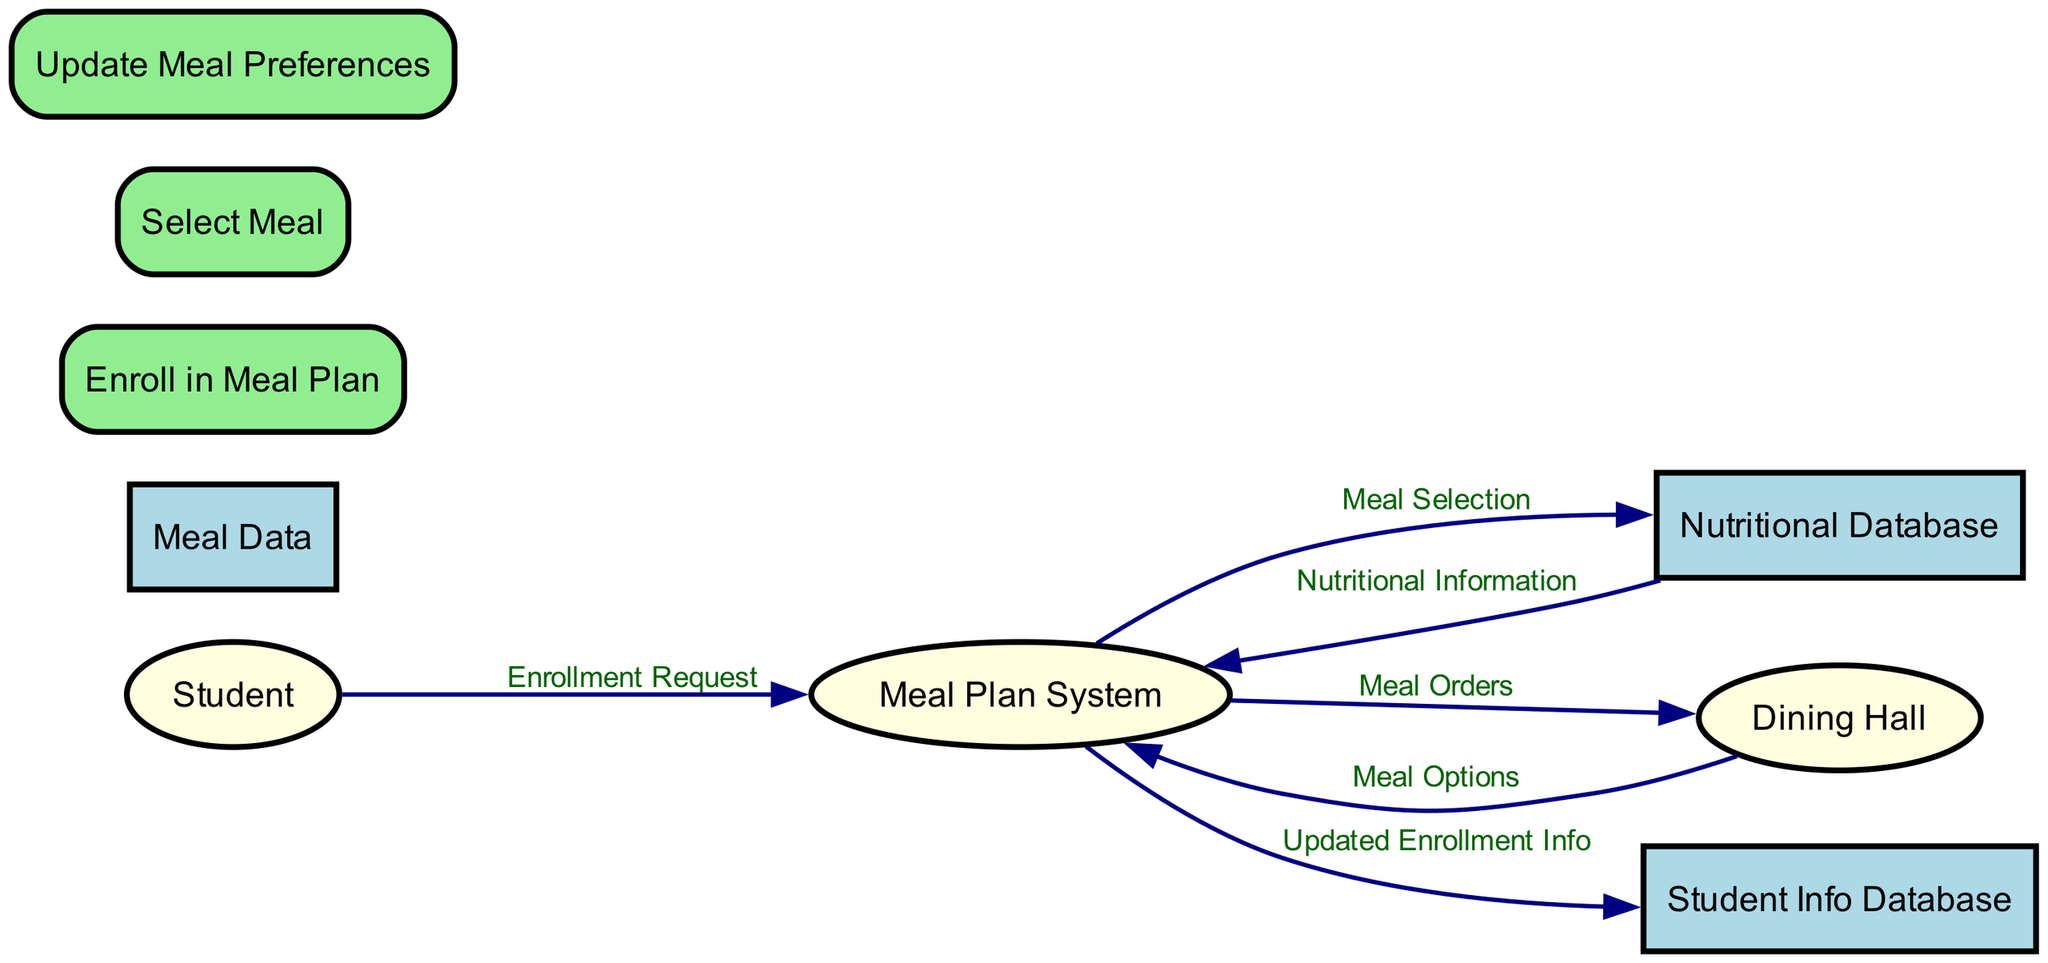What is the external entity that enrolls in the meal plan? The external entity responsible for enrolling in the meal plan is the Student, as indicated in the diagram where it connects to the "Enroll in Meal Plan" process.
Answer: Student How many processes are there in the diagram? The diagram includes three processes: "Enroll in Meal Plan," "Select Meal," and "Update Meal Preferences." Counting them gives us a total of three processes.
Answer: 3 What does the Student's Enrollment Request flow to? The Student's Enrollment Request flows to the Meal Plan System, which is identified in the data flow connections within the diagram.
Answer: Meal Plan System Which data store contains detailed meal options and their ingredients? The data store that contains detailed meal options and their ingredients is labeled as Meal Data, which can be seen in the section of data stores in the diagram.
Answer: Meal Data Which process outputs Nutritional Breakdown? The process that outputs Nutritional Breakdown is the "Select Meal" process, as it shows connections to both the Nutritional Database and outputs this specific information in the diagram.
Answer: Select Meal What is the flow of data from the Dining Hall to the Meal Plan System labeled as? The flow of data from the Dining Hall to the Meal Plan System is labeled as Meal Options, which can be found in the data flow connections illustrated between these entities.
Answer: Meal Options What do the Student Info Database and Meal Data have in common? Both the Student Info Database and Meal Data are classified as Data Stores in the diagram, consisting of information necessary for the processes involving the meal plan system.
Answer: Data Stores What type of diagram is represented here with respect to meal plans? The diagram is a Data Flow Diagram, which is evident from the way it represents how data flows between external entities, processes, and data stores in the context of the campus meal plan process.
Answer: Data Flow Diagram 